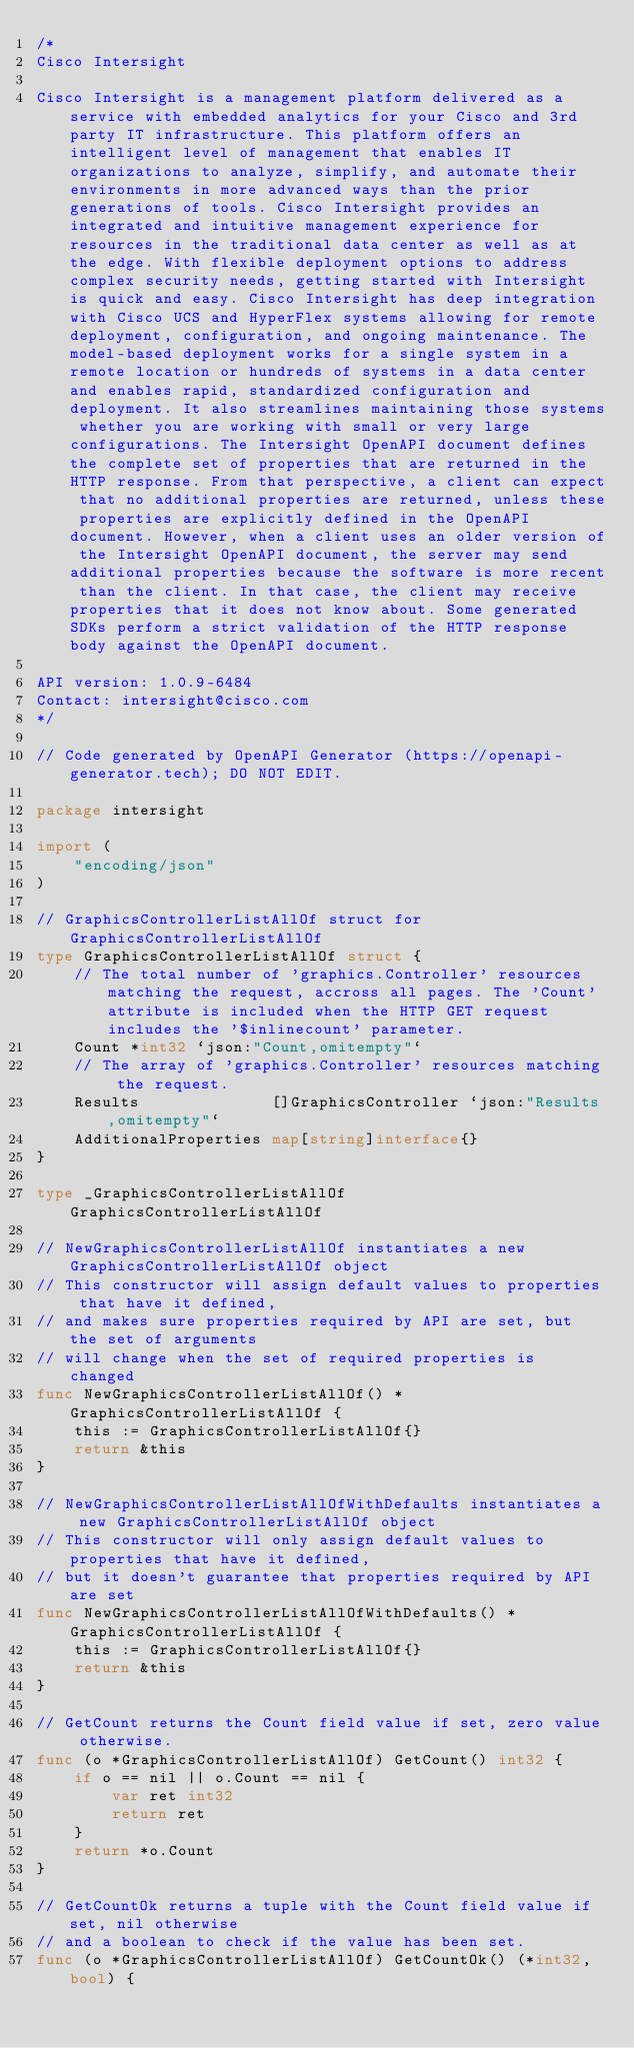Convert code to text. <code><loc_0><loc_0><loc_500><loc_500><_Go_>/*
Cisco Intersight

Cisco Intersight is a management platform delivered as a service with embedded analytics for your Cisco and 3rd party IT infrastructure. This platform offers an intelligent level of management that enables IT organizations to analyze, simplify, and automate their environments in more advanced ways than the prior generations of tools. Cisco Intersight provides an integrated and intuitive management experience for resources in the traditional data center as well as at the edge. With flexible deployment options to address complex security needs, getting started with Intersight is quick and easy. Cisco Intersight has deep integration with Cisco UCS and HyperFlex systems allowing for remote deployment, configuration, and ongoing maintenance. The model-based deployment works for a single system in a remote location or hundreds of systems in a data center and enables rapid, standardized configuration and deployment. It also streamlines maintaining those systems whether you are working with small or very large configurations. The Intersight OpenAPI document defines the complete set of properties that are returned in the HTTP response. From that perspective, a client can expect that no additional properties are returned, unless these properties are explicitly defined in the OpenAPI document. However, when a client uses an older version of the Intersight OpenAPI document, the server may send additional properties because the software is more recent than the client. In that case, the client may receive properties that it does not know about. Some generated SDKs perform a strict validation of the HTTP response body against the OpenAPI document.

API version: 1.0.9-6484
Contact: intersight@cisco.com
*/

// Code generated by OpenAPI Generator (https://openapi-generator.tech); DO NOT EDIT.

package intersight

import (
	"encoding/json"
)

// GraphicsControllerListAllOf struct for GraphicsControllerListAllOf
type GraphicsControllerListAllOf struct {
	// The total number of 'graphics.Controller' resources matching the request, accross all pages. The 'Count' attribute is included when the HTTP GET request includes the '$inlinecount' parameter.
	Count *int32 `json:"Count,omitempty"`
	// The array of 'graphics.Controller' resources matching the request.
	Results              []GraphicsController `json:"Results,omitempty"`
	AdditionalProperties map[string]interface{}
}

type _GraphicsControllerListAllOf GraphicsControllerListAllOf

// NewGraphicsControllerListAllOf instantiates a new GraphicsControllerListAllOf object
// This constructor will assign default values to properties that have it defined,
// and makes sure properties required by API are set, but the set of arguments
// will change when the set of required properties is changed
func NewGraphicsControllerListAllOf() *GraphicsControllerListAllOf {
	this := GraphicsControllerListAllOf{}
	return &this
}

// NewGraphicsControllerListAllOfWithDefaults instantiates a new GraphicsControllerListAllOf object
// This constructor will only assign default values to properties that have it defined,
// but it doesn't guarantee that properties required by API are set
func NewGraphicsControllerListAllOfWithDefaults() *GraphicsControllerListAllOf {
	this := GraphicsControllerListAllOf{}
	return &this
}

// GetCount returns the Count field value if set, zero value otherwise.
func (o *GraphicsControllerListAllOf) GetCount() int32 {
	if o == nil || o.Count == nil {
		var ret int32
		return ret
	}
	return *o.Count
}

// GetCountOk returns a tuple with the Count field value if set, nil otherwise
// and a boolean to check if the value has been set.
func (o *GraphicsControllerListAllOf) GetCountOk() (*int32, bool) {</code> 